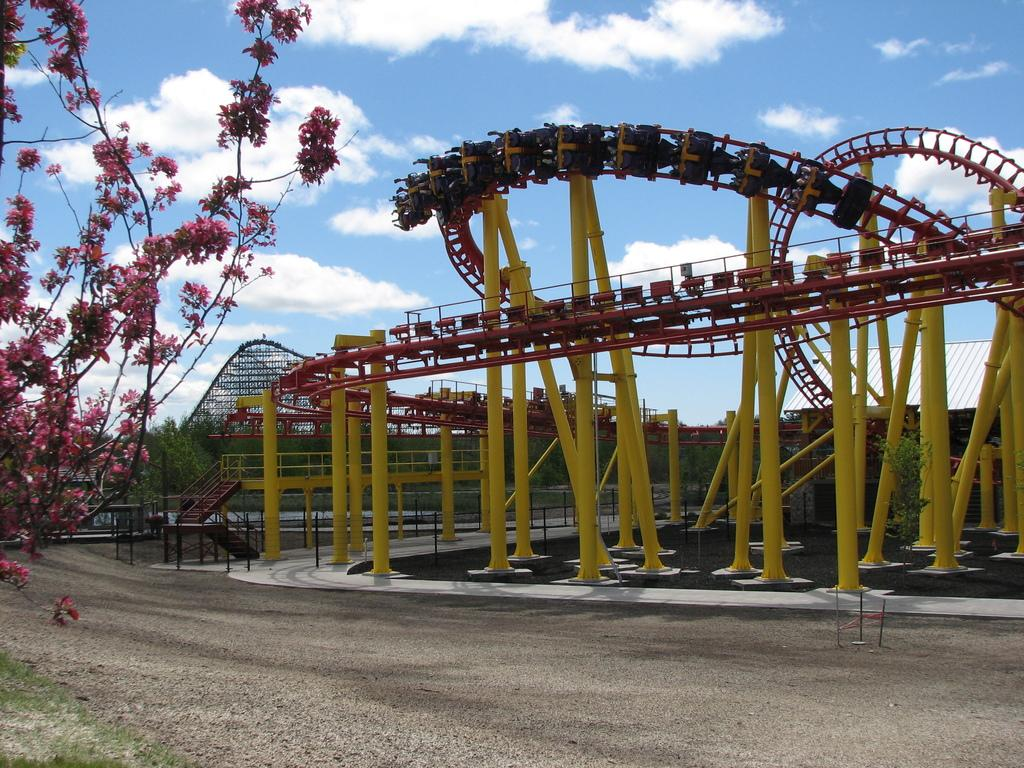What is the main subject of the image? There is an amusement ride in the image. What are the people in the image doing? There are people taking the ride in the image. What is the ground like in front of the ride? There is a plain ground in front of the ride. What can be seen on the left side of the image? There is a tree on the left side of the image. Where is the lunchroom located in the image? There is no lunchroom present in the image. What shape does the amusement ride form in the image? The shape of the amusement ride cannot be determined from the image alone. 